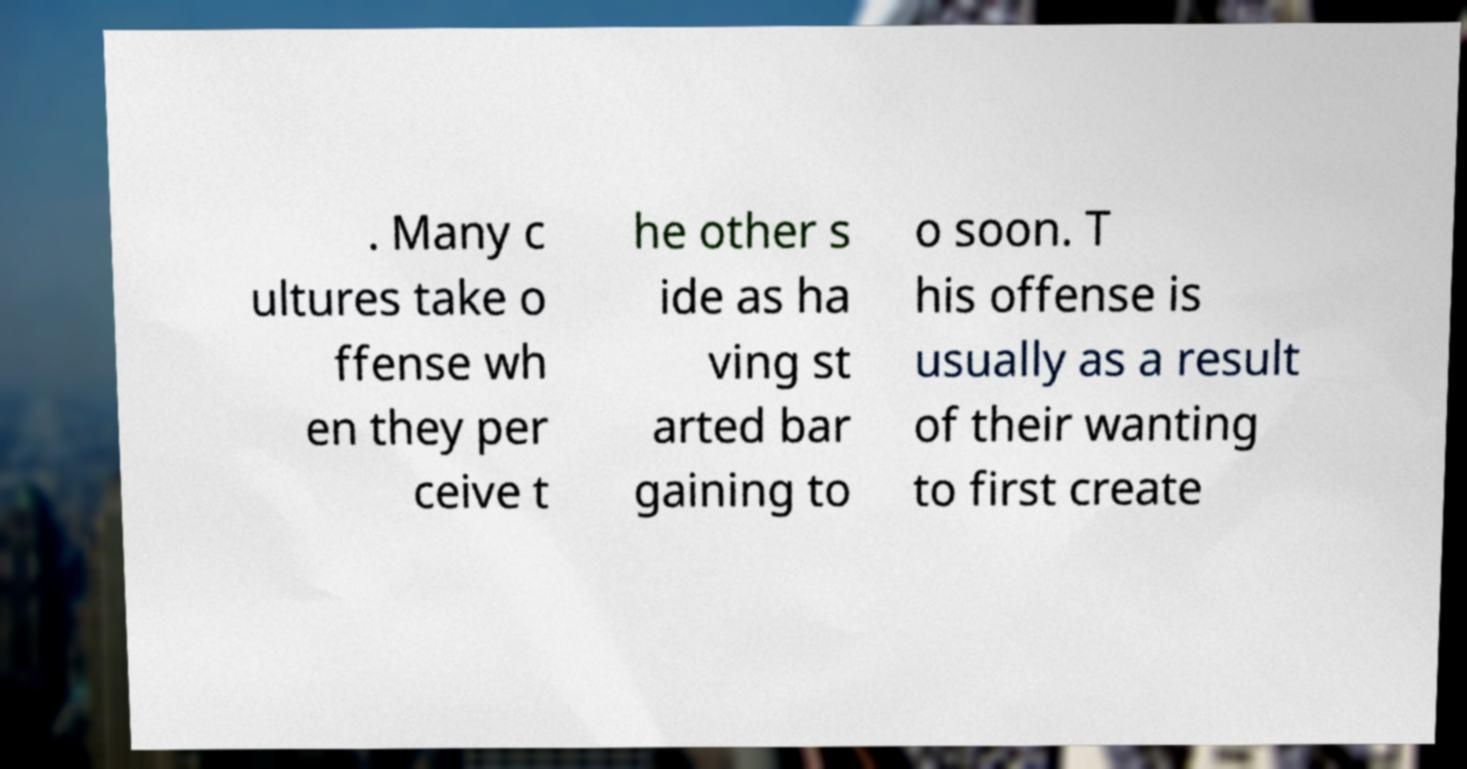Can you accurately transcribe the text from the provided image for me? . Many c ultures take o ffense wh en they per ceive t he other s ide as ha ving st arted bar gaining to o soon. T his offense is usually as a result of their wanting to first create 